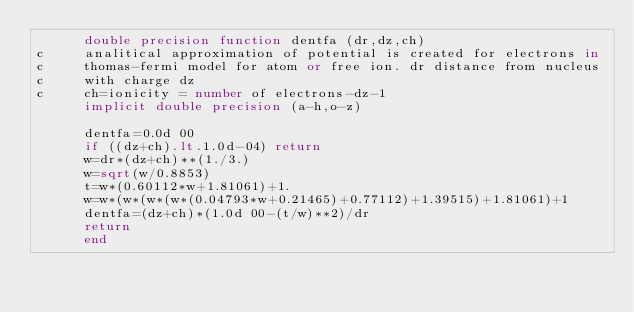Convert code to text. <code><loc_0><loc_0><loc_500><loc_500><_FORTRAN_>      double precision function dentfa (dr,dz,ch)
c     analitical approximation of potential is created for electrons in
c     thomas-fermi model for atom or free ion. dr distance from nucleus
c     with charge dz  
c     ch=ionicity = number of electrons-dz-1
      implicit double precision (a-h,o-z)
 
      dentfa=0.0d 00
      if ((dz+ch).lt.1.0d-04) return
      w=dr*(dz+ch)**(1./3.)
      w=sqrt(w/0.8853)
      t=w*(0.60112*w+1.81061)+1.
      w=w*(w*(w*(w*(0.04793*w+0.21465)+0.77112)+1.39515)+1.81061)+1
      dentfa=(dz+ch)*(1.0d 00-(t/w)**2)/dr
      return
      end
</code> 